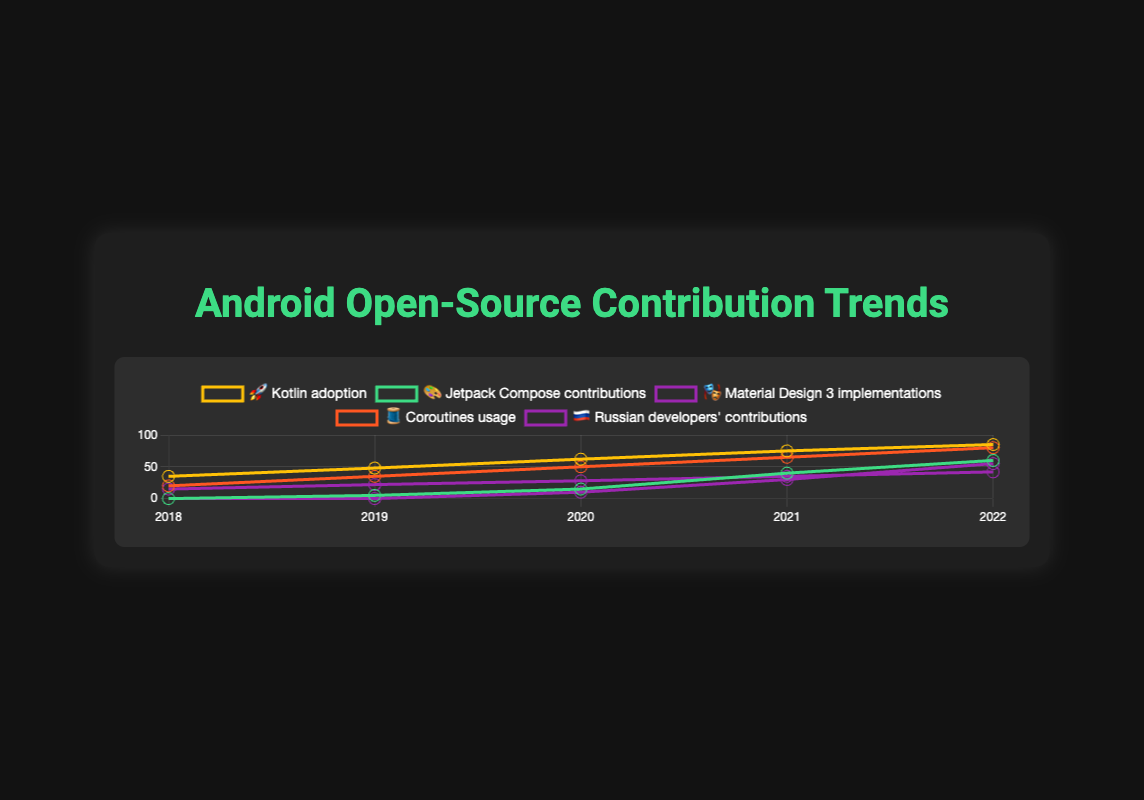What is the trend with the highest adoption rate in 2022? By observing the trends, we see that "Kotlin adoption 🚀" has the highest value of 85 in 2022.
Answer: Kotlin adoption 🚀 How did the contributions to Jetpack Compose 🎨 change between 2019 and 2020? Looking at the values for Jetpack Compose 🎨, it increased from 5 in 2019 to 15 in 2020, which is an increase of 10.
Answer: Increased by 10 Which trend started with the lowest value in 2018? In 2018, the trends "Jetpack Compose 🎨" and "Material Design 3 🎭" both started with a value of 0.
Answer: Jetpack Compose 🎨 and Material Design 3 🎭 What is the increase in Coroutines usage 🧵 from 2018 to 2022? The value for Coroutines usage 🧵 in 2018 is 20, and in 2022 it is 80. The increase is 80 - 20 = 60.
Answer: 60 How many trends showed contributions in 2018? By checking the values in 2018, trends "Kotlin adoption 🚀" (35), "Coroutines usage 🧵" (20), and "Russian developers' contributions 🇷🇺" (15) had contributions, making it 3 trends.
Answer: 3 Which trend shows the largest overall increase from 2018 to 2022? "Kotlin adoption 🚀" increased from 35 in 2018 to 85 in 2022. The total increase is 85 - 35 = 50. This is the largest among the data provided.
Answer: Kotlin adoption 🚀 Between 2021 and 2022, which trend had the smallest growth? By comparing the values for each trend between 2021 and 2022: "Kotlin adoption 🚀" (75 to 85, +10), "Jetpack Compose 🎨" (40 to 60, +20), "Material Design 3 implementations 🎭" (30 to 55, +25), "Coroutines usage 🧵" (65 to 80, +15), "Russian developers' contributions 🇷🇺" (35 to 42, +7). "Russian developers' contributions 🇷🇺" has the smallest growth of +7.
Answer: Russian developers' contributions 🇷🇺 What was the value of Material Design 3 🎭 implementations in 2020? Looking at the data, the value for Material Design 3 implementations 🎭 in 2020 is 10.
Answer: 10 Which year saw the highest number of contributions by Russian developers 🇷🇺? By observing the trend for "Russian developers' contributions 🇷🇺", the highest value is in 2022, with a value of 42.
Answer: 2022 In which year did Jetpack Compose contributions 🎨 surpass 15? Observing the values for Jetpack Compose 🎨, it surpasses 15 starting in 2021, with a value of 40.
Answer: 2021 